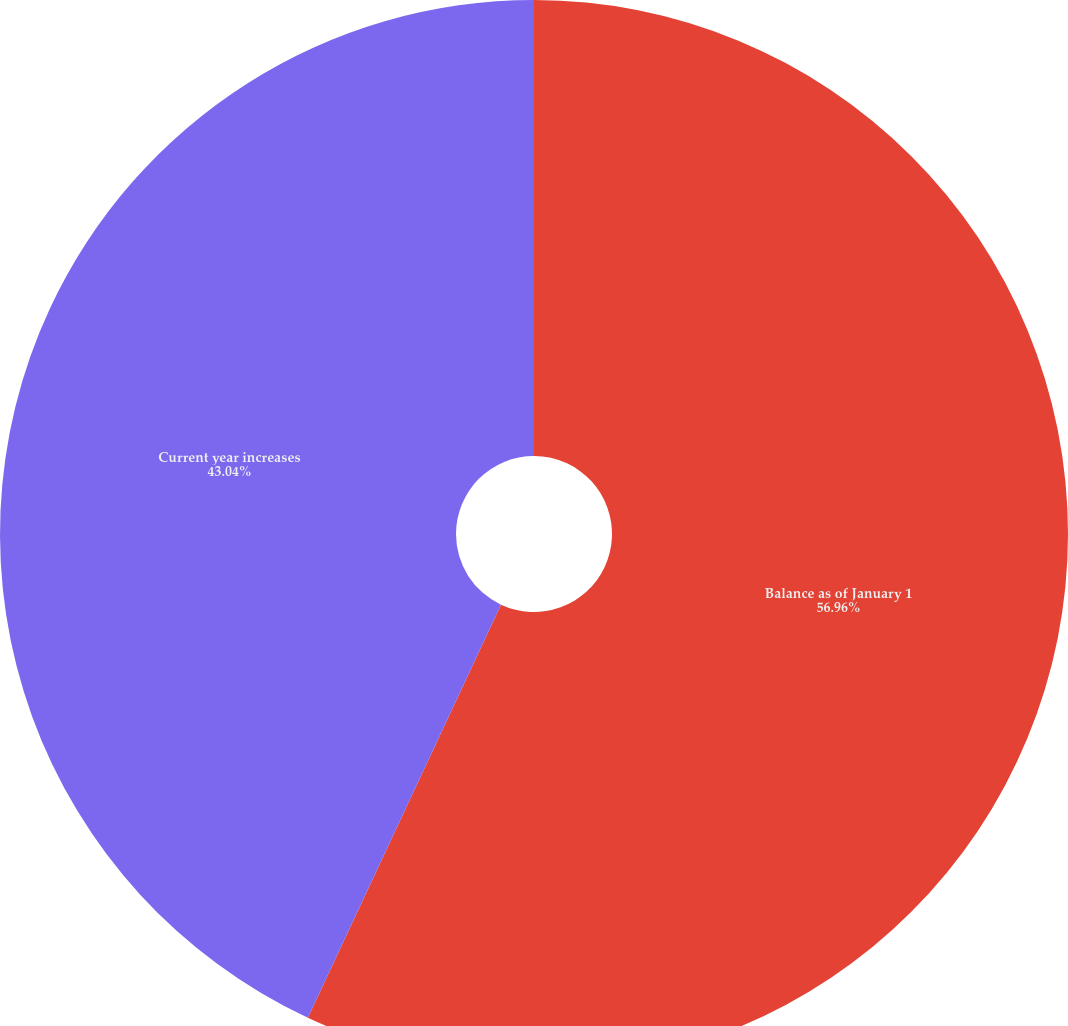<chart> <loc_0><loc_0><loc_500><loc_500><pie_chart><fcel>Balance as of January 1<fcel>Current year increases<nl><fcel>56.96%<fcel>43.04%<nl></chart> 